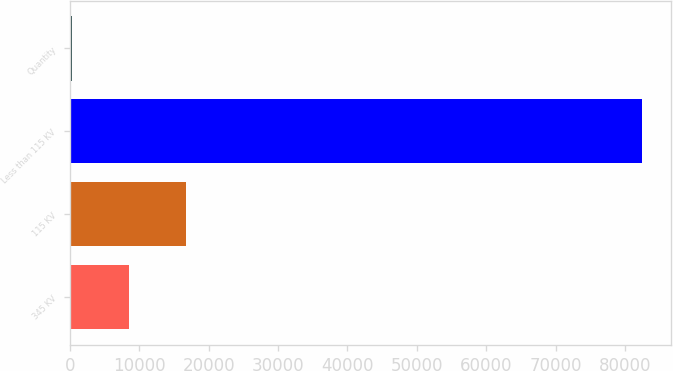Convert chart. <chart><loc_0><loc_0><loc_500><loc_500><bar_chart><fcel>345 KV<fcel>115 KV<fcel>Less than 115 KV<fcel>Quantity<nl><fcel>8579.6<fcel>16787.2<fcel>82448<fcel>372<nl></chart> 